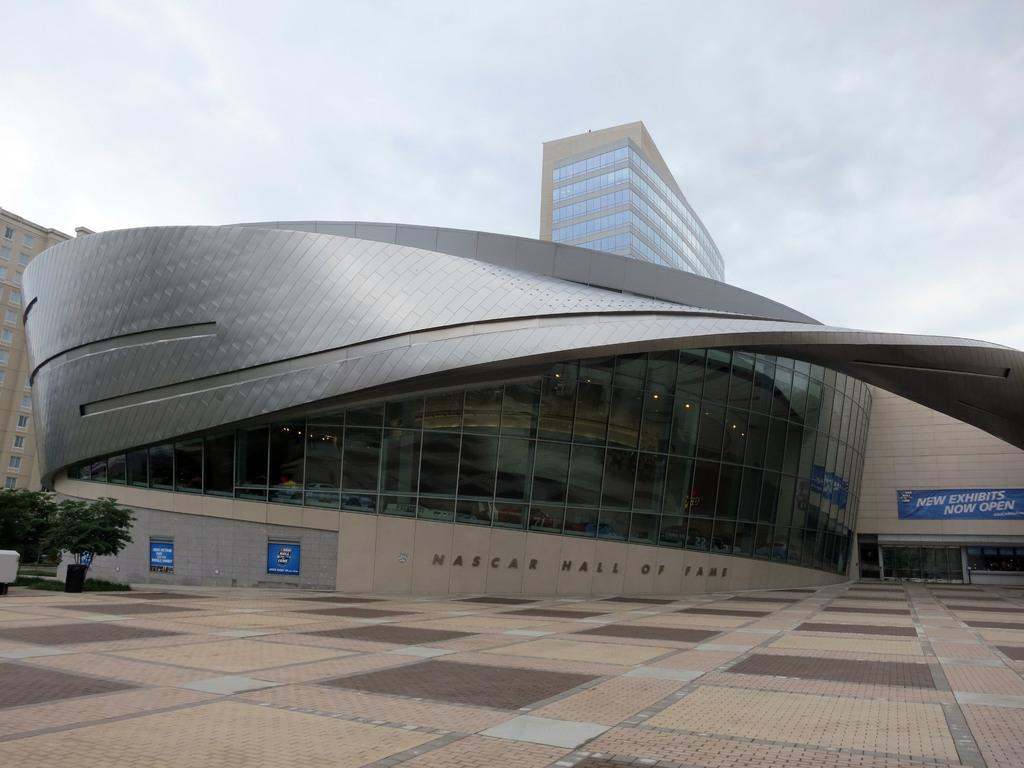<image>
Write a terse but informative summary of the picture. At the Nascar Hall of Fame, new exhibits are now open. 